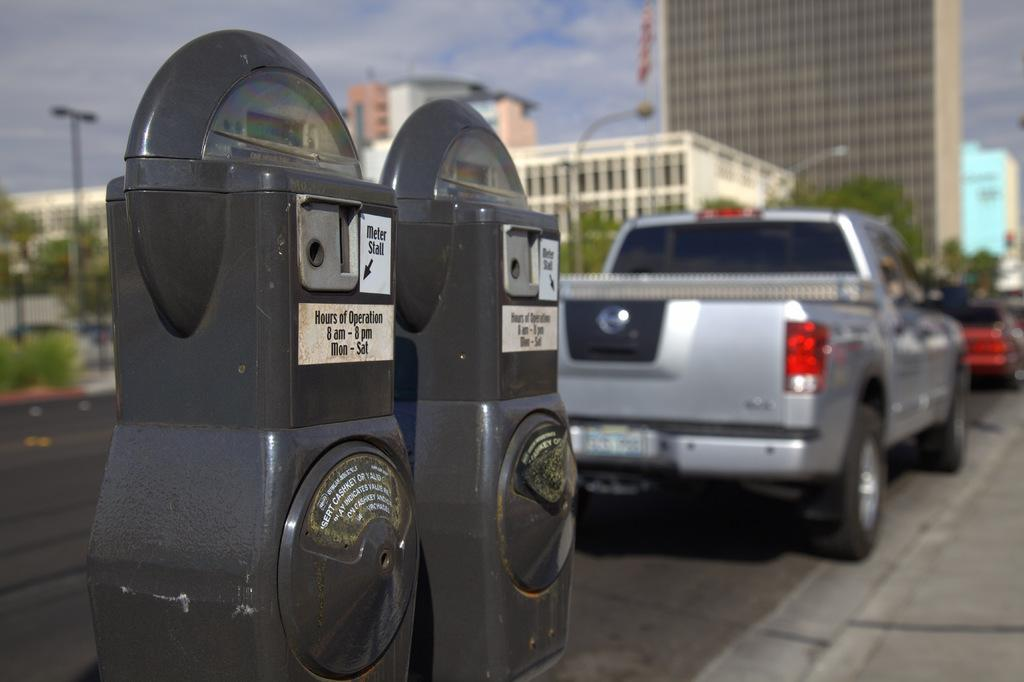Provide a one-sentence caption for the provided image. Two meters on the road indicate their hours of operation. 